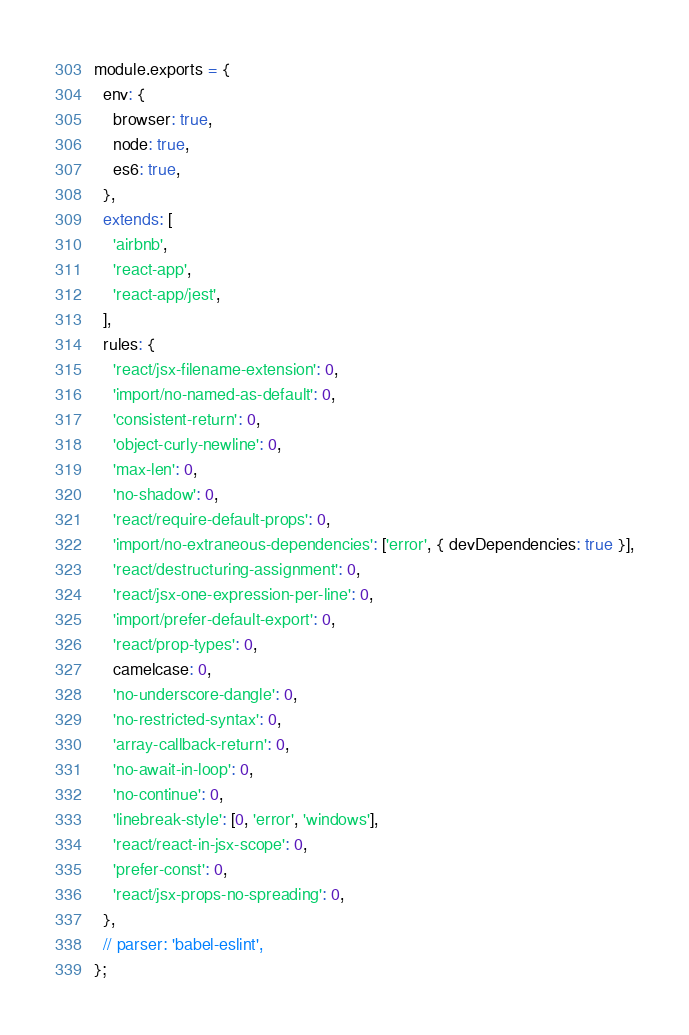Convert code to text. <code><loc_0><loc_0><loc_500><loc_500><_JavaScript_>module.exports = {
  env: {
    browser: true,
    node: true,
    es6: true,
  },
  extends: [
    'airbnb',
    'react-app',
    'react-app/jest',
  ],
  rules: {
    'react/jsx-filename-extension': 0,
    'import/no-named-as-default': 0,
    'consistent-return': 0,
    'object-curly-newline': 0,
    'max-len': 0,
    'no-shadow': 0,
    'react/require-default-props': 0,
    'import/no-extraneous-dependencies': ['error', { devDependencies: true }],
    'react/destructuring-assignment': 0,
    'react/jsx-one-expression-per-line': 0,
    'import/prefer-default-export': 0,
    'react/prop-types': 0,
    camelcase: 0,
    'no-underscore-dangle': 0,
    'no-restricted-syntax': 0,
    'array-callback-return': 0,
    'no-await-in-loop': 0,
    'no-continue': 0,
    'linebreak-style': [0, 'error', 'windows'],
    'react/react-in-jsx-scope': 0,
    'prefer-const': 0,
    'react/jsx-props-no-spreading': 0,
  },
  // parser: 'babel-eslint',
};
</code> 